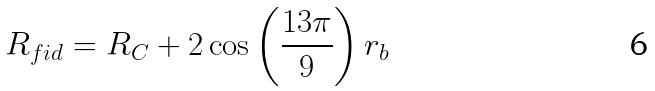Convert formula to latex. <formula><loc_0><loc_0><loc_500><loc_500>R _ { f i d } = R _ { C } + 2 \cos \left ( { \frac { 1 3 \pi } { 9 } } \right ) r _ { b }</formula> 